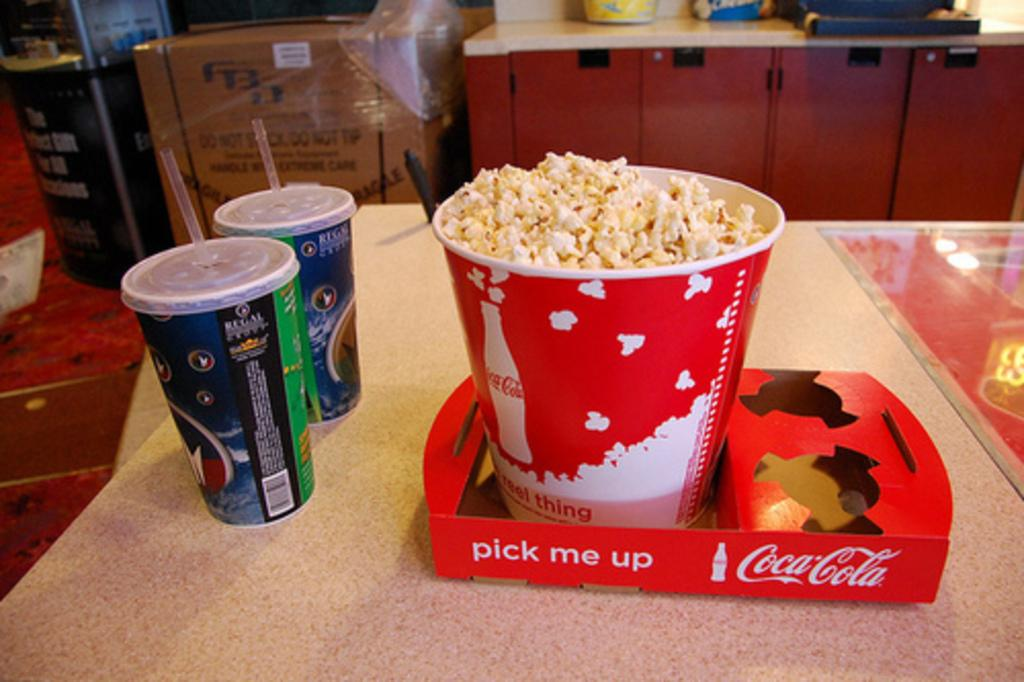What type of snack is in the tub in the image? There is popcorn in a tub in the image. What can be found in the glasses with straws? The glasses with straws contain an unspecified beverage. What is on the table in the image? There are objects on the table in the image, but their specific nature is not mentioned in the facts. What is visible in the background of the image? There is a cardboard box and the floor in the background of the image, along with other unspecified objects. Can you hear the kitty crying in the image? There is no kitty or any indication of sound in the image. How does the cardboard box move in the image? The cardboard box does not move in the image; it is stationary in the background. 